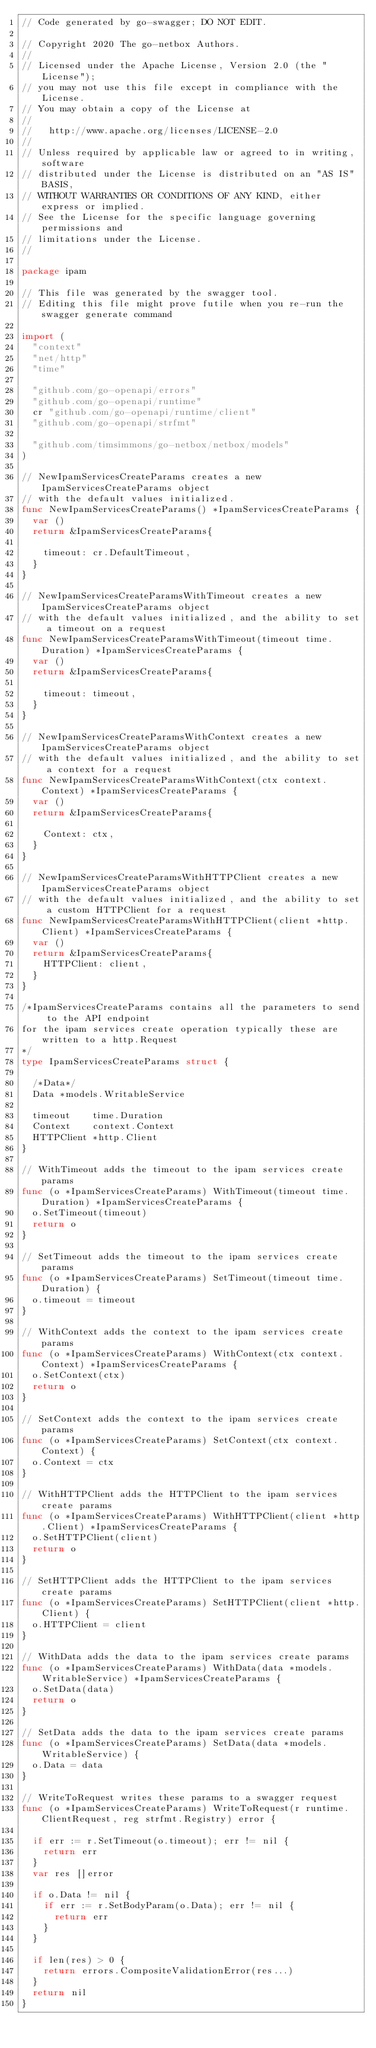Convert code to text. <code><loc_0><loc_0><loc_500><loc_500><_Go_>// Code generated by go-swagger; DO NOT EDIT.

// Copyright 2020 The go-netbox Authors.
//
// Licensed under the Apache License, Version 2.0 (the "License");
// you may not use this file except in compliance with the License.
// You may obtain a copy of the License at
//
//   http://www.apache.org/licenses/LICENSE-2.0
//
// Unless required by applicable law or agreed to in writing, software
// distributed under the License is distributed on an "AS IS" BASIS,
// WITHOUT WARRANTIES OR CONDITIONS OF ANY KIND, either express or implied.
// See the License for the specific language governing permissions and
// limitations under the License.
//

package ipam

// This file was generated by the swagger tool.
// Editing this file might prove futile when you re-run the swagger generate command

import (
	"context"
	"net/http"
	"time"

	"github.com/go-openapi/errors"
	"github.com/go-openapi/runtime"
	cr "github.com/go-openapi/runtime/client"
	"github.com/go-openapi/strfmt"

	"github.com/timsimmons/go-netbox/netbox/models"
)

// NewIpamServicesCreateParams creates a new IpamServicesCreateParams object
// with the default values initialized.
func NewIpamServicesCreateParams() *IpamServicesCreateParams {
	var ()
	return &IpamServicesCreateParams{

		timeout: cr.DefaultTimeout,
	}
}

// NewIpamServicesCreateParamsWithTimeout creates a new IpamServicesCreateParams object
// with the default values initialized, and the ability to set a timeout on a request
func NewIpamServicesCreateParamsWithTimeout(timeout time.Duration) *IpamServicesCreateParams {
	var ()
	return &IpamServicesCreateParams{

		timeout: timeout,
	}
}

// NewIpamServicesCreateParamsWithContext creates a new IpamServicesCreateParams object
// with the default values initialized, and the ability to set a context for a request
func NewIpamServicesCreateParamsWithContext(ctx context.Context) *IpamServicesCreateParams {
	var ()
	return &IpamServicesCreateParams{

		Context: ctx,
	}
}

// NewIpamServicesCreateParamsWithHTTPClient creates a new IpamServicesCreateParams object
// with the default values initialized, and the ability to set a custom HTTPClient for a request
func NewIpamServicesCreateParamsWithHTTPClient(client *http.Client) *IpamServicesCreateParams {
	var ()
	return &IpamServicesCreateParams{
		HTTPClient: client,
	}
}

/*IpamServicesCreateParams contains all the parameters to send to the API endpoint
for the ipam services create operation typically these are written to a http.Request
*/
type IpamServicesCreateParams struct {

	/*Data*/
	Data *models.WritableService

	timeout    time.Duration
	Context    context.Context
	HTTPClient *http.Client
}

// WithTimeout adds the timeout to the ipam services create params
func (o *IpamServicesCreateParams) WithTimeout(timeout time.Duration) *IpamServicesCreateParams {
	o.SetTimeout(timeout)
	return o
}

// SetTimeout adds the timeout to the ipam services create params
func (o *IpamServicesCreateParams) SetTimeout(timeout time.Duration) {
	o.timeout = timeout
}

// WithContext adds the context to the ipam services create params
func (o *IpamServicesCreateParams) WithContext(ctx context.Context) *IpamServicesCreateParams {
	o.SetContext(ctx)
	return o
}

// SetContext adds the context to the ipam services create params
func (o *IpamServicesCreateParams) SetContext(ctx context.Context) {
	o.Context = ctx
}

// WithHTTPClient adds the HTTPClient to the ipam services create params
func (o *IpamServicesCreateParams) WithHTTPClient(client *http.Client) *IpamServicesCreateParams {
	o.SetHTTPClient(client)
	return o
}

// SetHTTPClient adds the HTTPClient to the ipam services create params
func (o *IpamServicesCreateParams) SetHTTPClient(client *http.Client) {
	o.HTTPClient = client
}

// WithData adds the data to the ipam services create params
func (o *IpamServicesCreateParams) WithData(data *models.WritableService) *IpamServicesCreateParams {
	o.SetData(data)
	return o
}

// SetData adds the data to the ipam services create params
func (o *IpamServicesCreateParams) SetData(data *models.WritableService) {
	o.Data = data
}

// WriteToRequest writes these params to a swagger request
func (o *IpamServicesCreateParams) WriteToRequest(r runtime.ClientRequest, reg strfmt.Registry) error {

	if err := r.SetTimeout(o.timeout); err != nil {
		return err
	}
	var res []error

	if o.Data != nil {
		if err := r.SetBodyParam(o.Data); err != nil {
			return err
		}
	}

	if len(res) > 0 {
		return errors.CompositeValidationError(res...)
	}
	return nil
}
</code> 